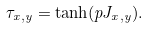Convert formula to latex. <formula><loc_0><loc_0><loc_500><loc_500>\tau _ { x , y } = \tanh ( p J _ { x , y } ) .</formula> 